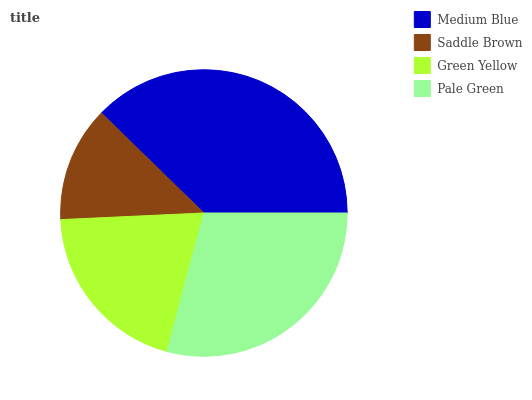Is Saddle Brown the minimum?
Answer yes or no. Yes. Is Medium Blue the maximum?
Answer yes or no. Yes. Is Green Yellow the minimum?
Answer yes or no. No. Is Green Yellow the maximum?
Answer yes or no. No. Is Green Yellow greater than Saddle Brown?
Answer yes or no. Yes. Is Saddle Brown less than Green Yellow?
Answer yes or no. Yes. Is Saddle Brown greater than Green Yellow?
Answer yes or no. No. Is Green Yellow less than Saddle Brown?
Answer yes or no. No. Is Pale Green the high median?
Answer yes or no. Yes. Is Green Yellow the low median?
Answer yes or no. Yes. Is Green Yellow the high median?
Answer yes or no. No. Is Pale Green the low median?
Answer yes or no. No. 